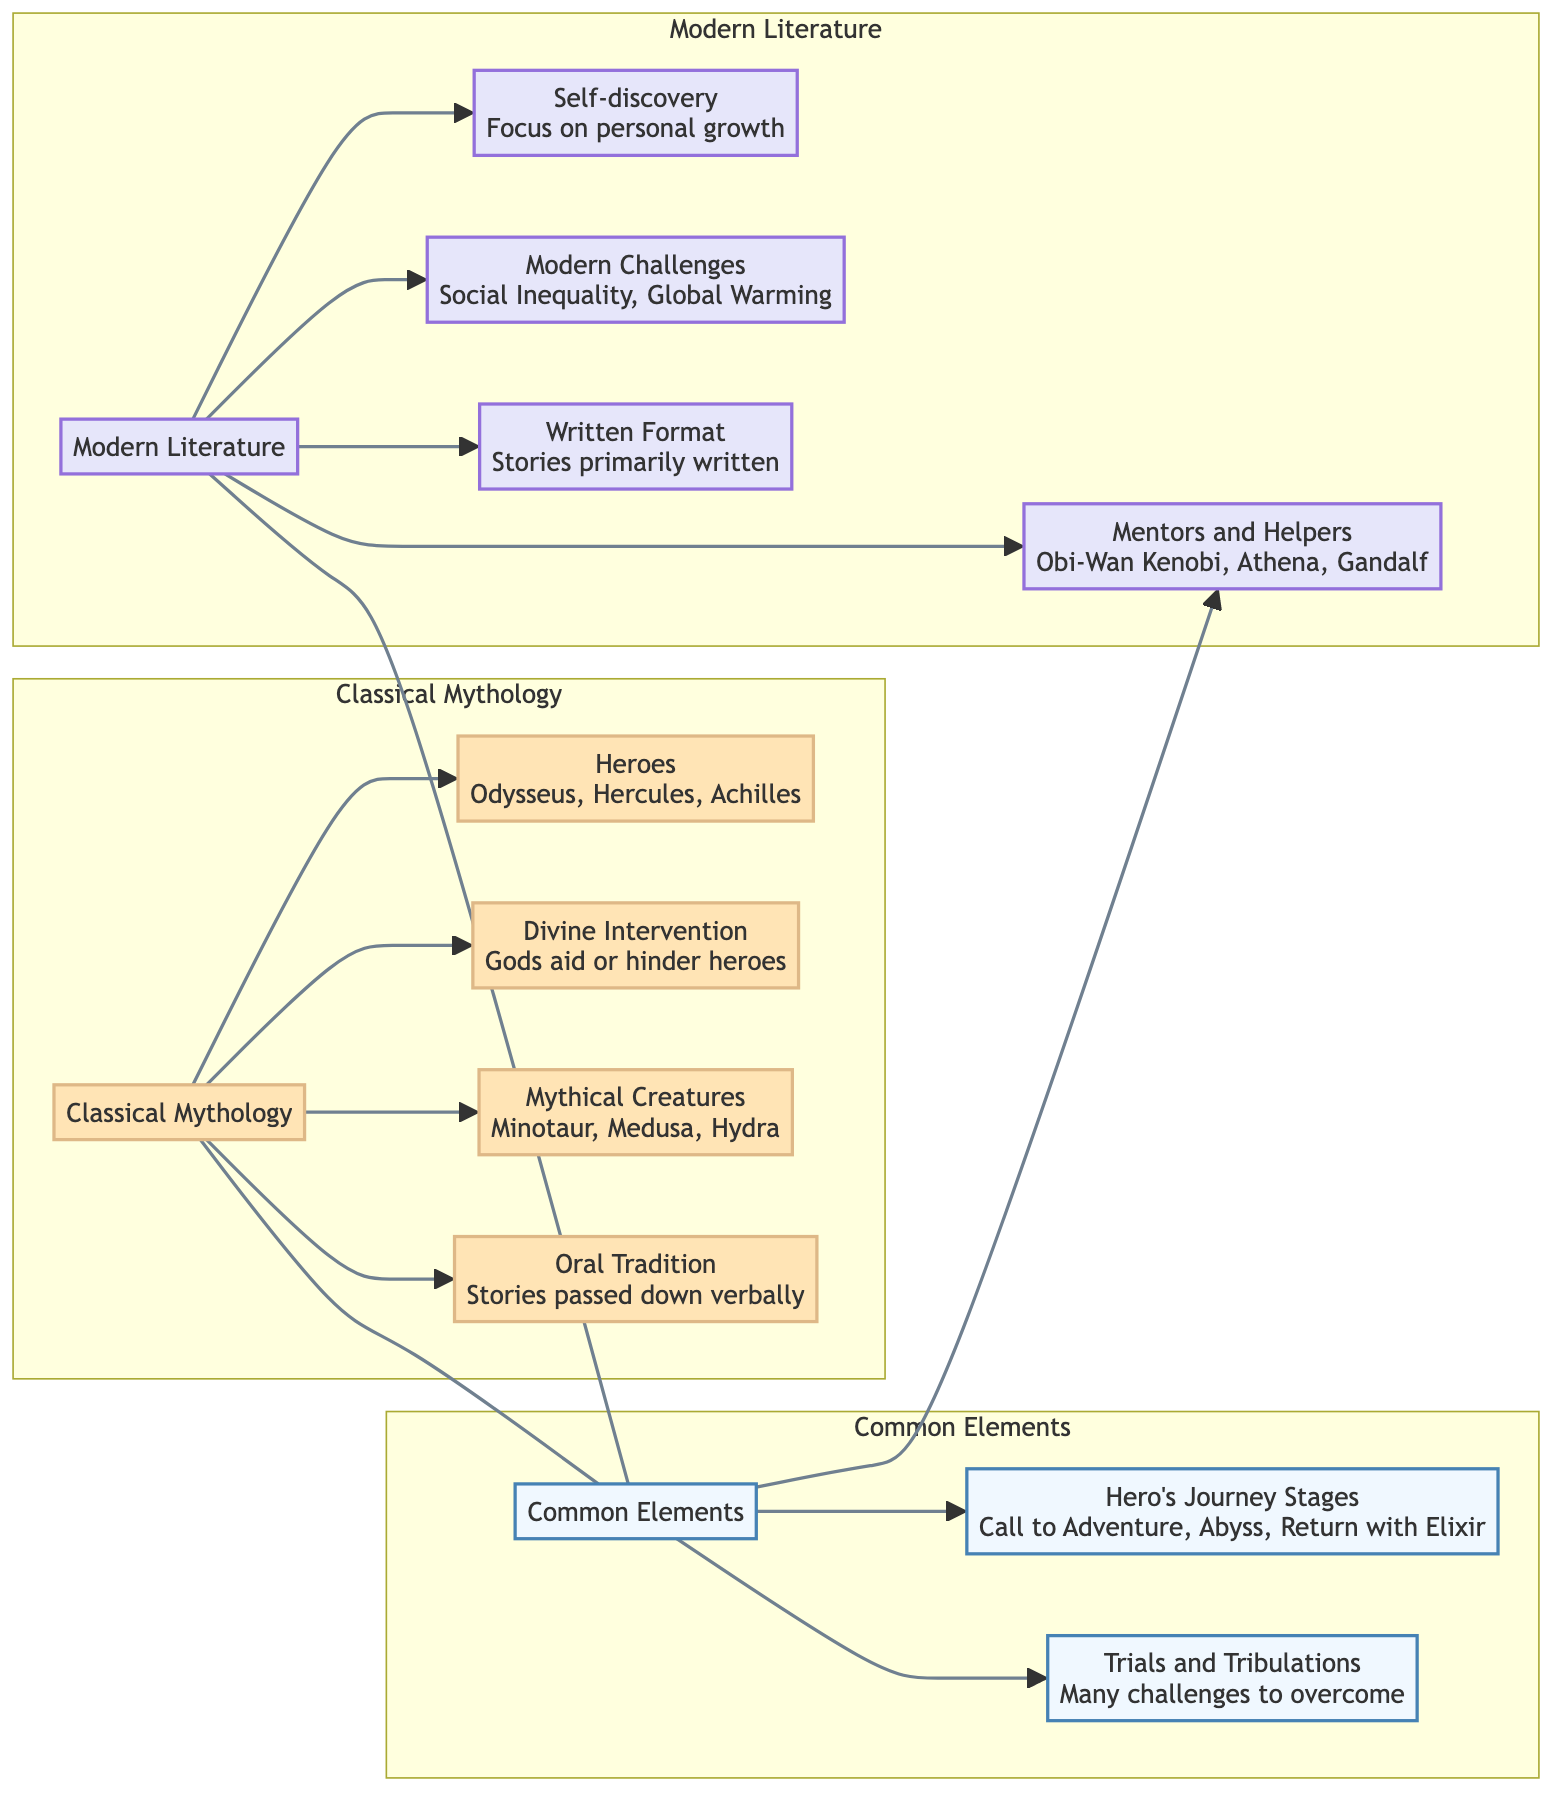What heroes are listed in Classical Mythology? The diagram shows "Odysseus, Hercules, Achilles" as the heroes in Classical Mythology. This information is found in the section labeled "Heroes" under the subgraph for Classical Mythology.
Answer: Odysseus, Hercules, Achilles What common element describes the challenges faced by heroes? The common element labeled "Trials and Tribulations" indicates that heroes face "Many challenges to overcome." This is in the Common Elements section, which connects both Classical Mythology and Modern Literature.
Answer: Many challenges to overcome How many heroes are named in Modern Literature? In the Modern Literature section, three heroes are listed: Harry Potter, Katniss Everdeen, and Frodo. Counting these names gives the total.
Answer: 3 Which element emphasizes Divine Intervention in Classical Mythology? The diagram has a node labeled "Divine Intervention" under Classical Mythology that specifies "Gods aid or hinder heroes," indicating that it emphasizes this aspect of heroes' journeys.
Answer: Gods aid or hinder heroes What is shared between both Classical Mythology and Modern Literature in terms of mentor figures? The node labeled "Mentors and Helpers" describes figures such as "Obi-Wan Kenobi, Athena, Gandalf" that are common to both genres, showing the role of mentor characters.
Answer: Obi-Wan Kenobi, Athena, Gandalf Which specific modern challenges are mentioned in the Modern Literature section? The diagram lists "Social Inequality" and "Global Warming" as modern challenges under the Modern Literature subgraph. This information is directly taken from the node for Modern Challenges.
Answer: Social Inequality, Global Warming What color represents the Classical Mythology section in the diagram? The Classical Mythology section is filled with a light orange color #FFE4B5, as indicated in the section's class definition of the diagram.
Answer: Light orange How do the journeys of heroes in both domains start? The node "Hero's Journey Stages" under Common Elements mentions "Call to Adventure," which indicates a common starting point for both domains in their hero's journey.
Answer: Call to Adventure What feature distinguishes Modern Literature regarding story format? The node labeled "Written Format" under Modern Literature indicates that stories are primarily written, distinguishing this characteristic from Classical Mythology's oral tradition.
Answer: Written Format 